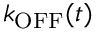Convert formula to latex. <formula><loc_0><loc_0><loc_500><loc_500>k _ { O F F } ( t )</formula> 